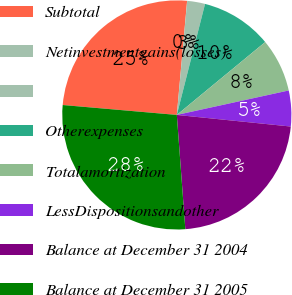Convert chart. <chart><loc_0><loc_0><loc_500><loc_500><pie_chart><fcel>Subtotal<fcel>Netinvestmentgains(losses)<fcel>Unnamed: 2<fcel>Otherexpenses<fcel>Totalamortization<fcel>LessDispositionsandother<fcel>Balance at December 31 2004<fcel>Balance at December 31 2005<nl><fcel>25.05%<fcel>0.01%<fcel>2.52%<fcel>10.06%<fcel>7.55%<fcel>5.04%<fcel>22.2%<fcel>27.56%<nl></chart> 